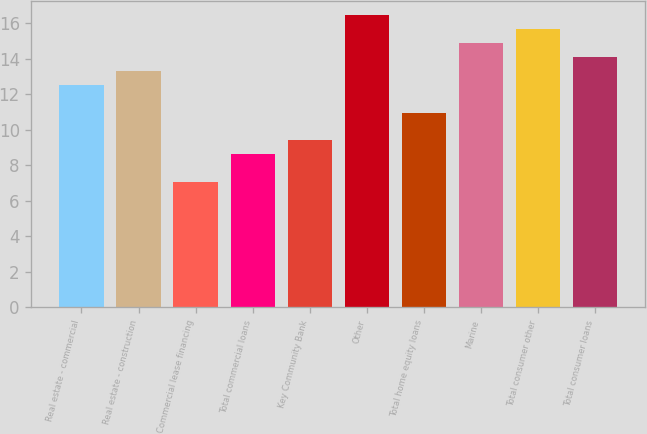Convert chart. <chart><loc_0><loc_0><loc_500><loc_500><bar_chart><fcel>Real estate - commercial<fcel>Real estate - construction<fcel>Commercial lease financing<fcel>Total commercial loans<fcel>Key Community Bank<fcel>Other<fcel>Total home equity loans<fcel>Marine<fcel>Total consumer other<fcel>Total consumer loans<nl><fcel>12.53<fcel>13.31<fcel>7.07<fcel>8.63<fcel>9.41<fcel>16.43<fcel>10.97<fcel>14.87<fcel>15.65<fcel>14.09<nl></chart> 